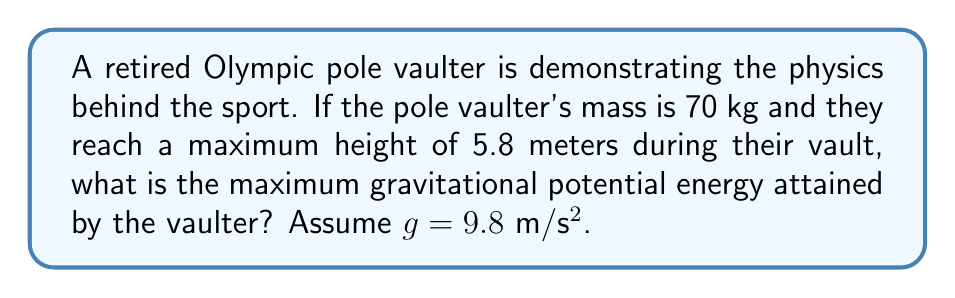Can you solve this math problem? To solve this problem, we need to use the formula for gravitational potential energy:

$$E_p = mgh$$

Where:
$E_p$ = Gravitational potential energy (in Joules, J)
$m$ = Mass of the object (in kilograms, kg)
$g$ = Acceleration due to gravity (in meters per second squared, m/s²)
$h$ = Height reached (in meters, m)

Given:
$m = 70$ kg
$g = 9.8$ m/s²
$h = 5.8$ m

Let's substitute these values into the equation:

$$E_p = 70 \text{ kg} \times 9.8 \text{ m/s²} \times 5.8 \text{ m}$$

$$E_p = 3,968.4 \text{ J}$$

Therefore, the maximum gravitational potential energy attained by the pole vaulter is 3,968.4 Joules.
Answer: 3,968.4 J 